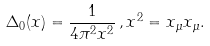<formula> <loc_0><loc_0><loc_500><loc_500>\Delta _ { 0 } ( x ) = \frac { 1 } { 4 \pi ^ { 2 } x ^ { 2 } } \, , x ^ { 2 } = x _ { \mu } x _ { \mu } .</formula> 